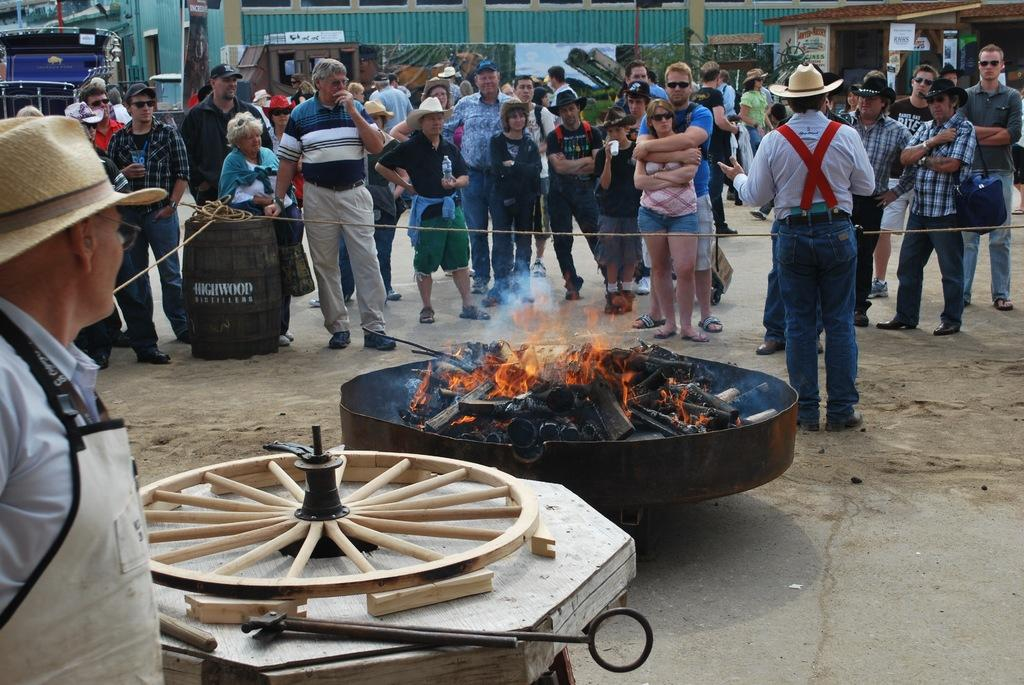What can be seen in the image involving a group of people? There is a group of people in the image. What is the fire in the image contained within? The fire is in a metal tray. What object with a circular shape is present in the image? There is a wheel in the image. Can you describe the man in the image? The man in the image is standing and wearing a hat. What type of structure is visible in the image? There is a building in the image. Where is the kitty playing with a pail in the image? There is no kitty or pail present in the image. What type of jar is being used to store the fire in the image? There is no jar present in the image; the fire is in a metal tray. 